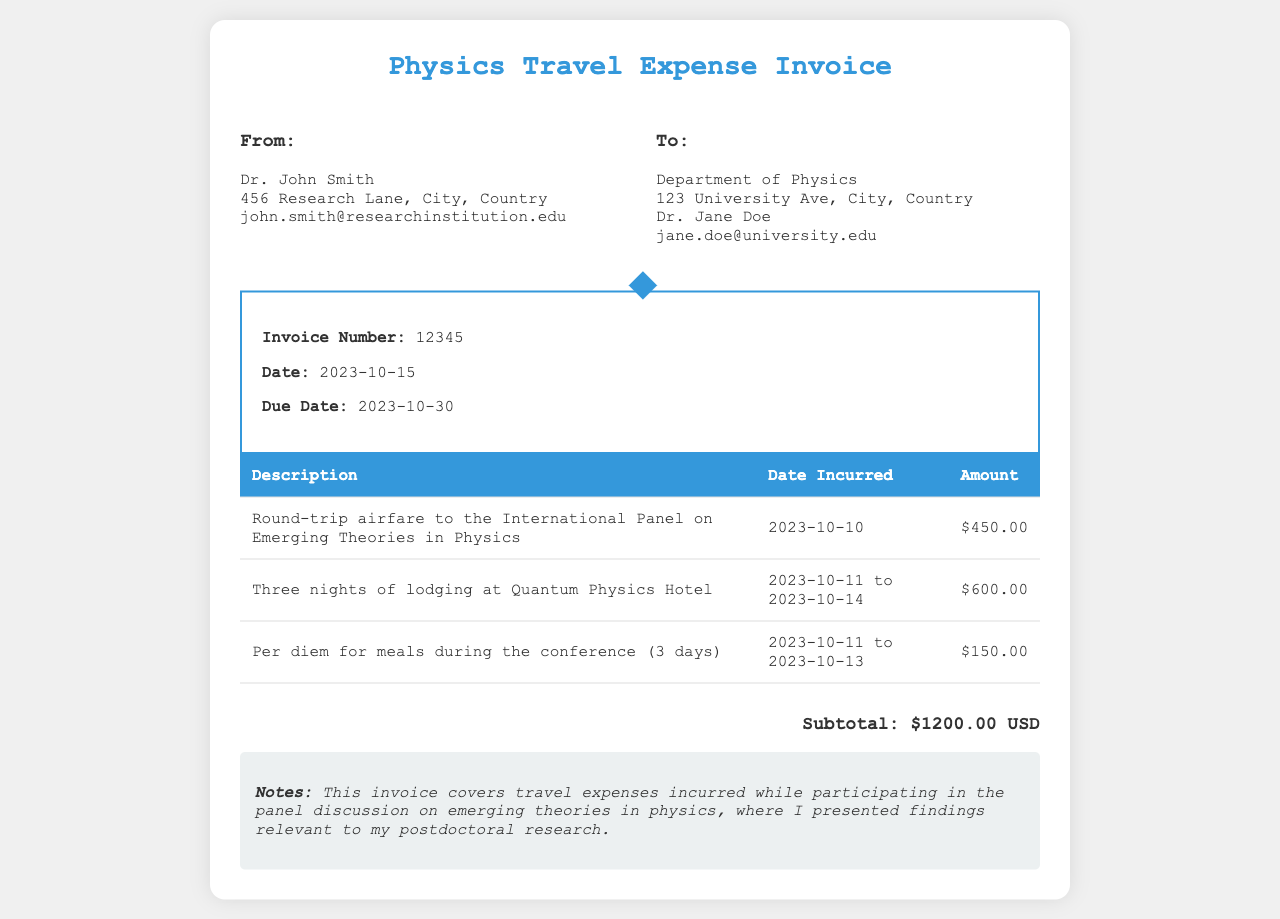What is the invoice number? The invoice number is listed in the document under a specific header.
Answer: 12345 Who is the recipient of the invoice? The 'To' section of the invoice provides the name of the recipient.
Answer: Department of Physics What is the total lodging cost? The total lodging cost can be found in the line item for lodging in the itemized table.
Answer: $600.00 What dates did the lodging cover? The dates for lodging are indicated next to the lodging description in the invoice.
Answer: 2023-10-11 to 2023-10-14 What is included in the per diem for meals? The description of the meals charge provides details on its contents in the invoice.
Answer: Per diem for meals during the conference What is the due date of the invoice? The document specifies a due date after the invoice date.
Answer: 2023-10-30 What was the purpose of the travel expenses? The invoice notes indicate the reason for the incurred expenses.
Answer: Participating in the panel discussion How many nights of lodging were billed? The lodging description specifies the duration of the stay.
Answer: Three nights What is the subtotal amount on the invoice? The subtotal amount is summarized at the bottom of the itemized table.
Answer: $1200.00 USD 